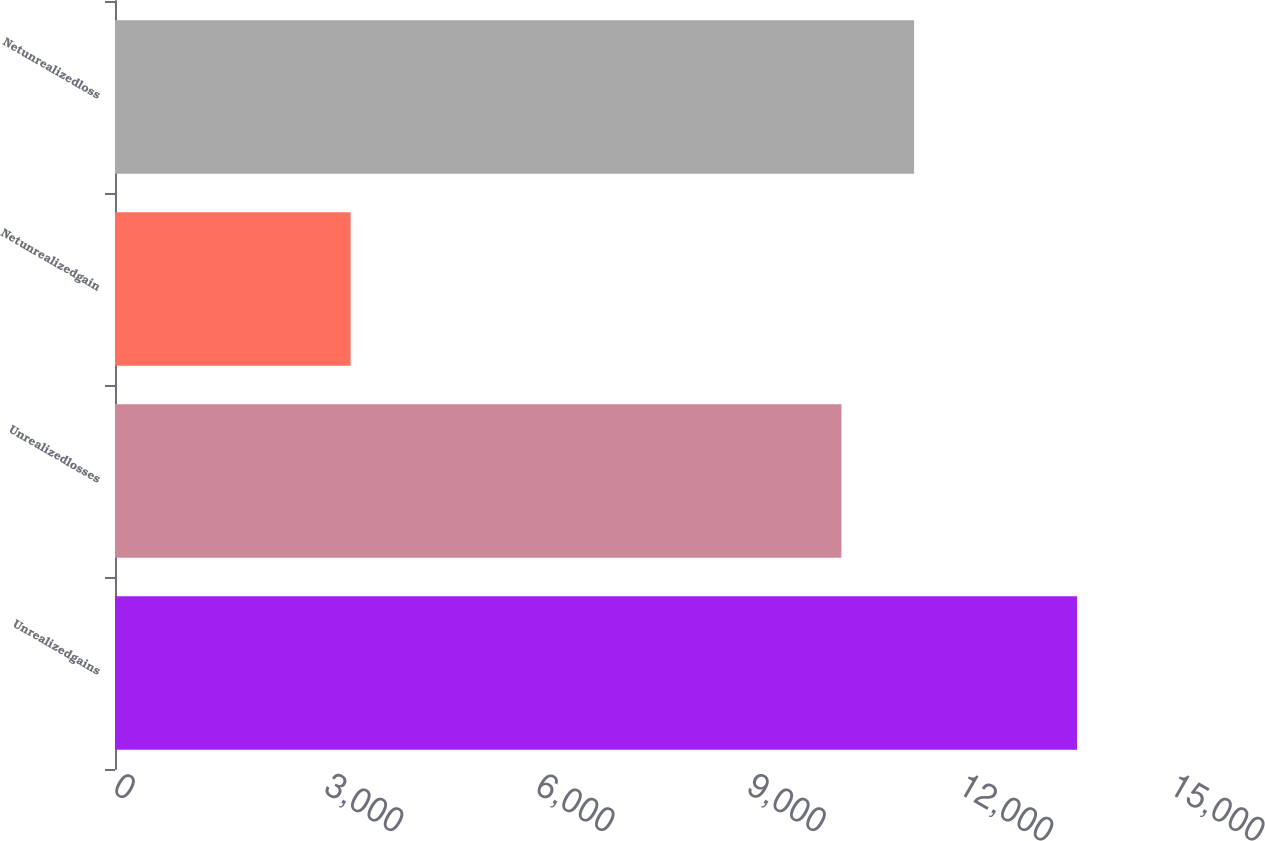<chart> <loc_0><loc_0><loc_500><loc_500><bar_chart><fcel>Unrealizedgains<fcel>Unrealizedlosses<fcel>Netunrealizedgain<fcel>Netunrealizedloss<nl><fcel>13666<fcel>10319<fcel>3347<fcel>11350.9<nl></chart> 